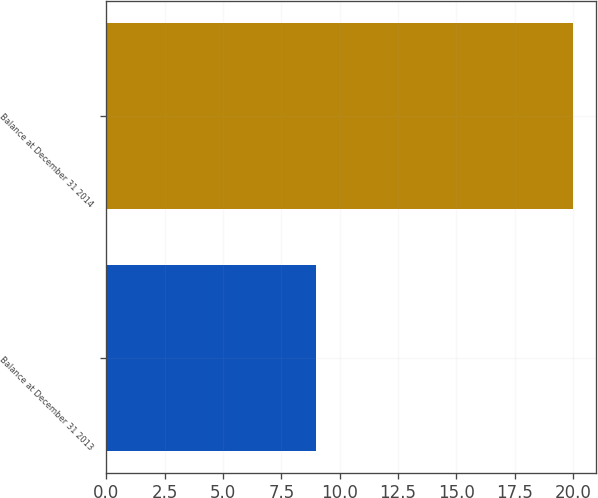<chart> <loc_0><loc_0><loc_500><loc_500><bar_chart><fcel>Balance at December 31 2013<fcel>Balance at December 31 2014<nl><fcel>9<fcel>20<nl></chart> 